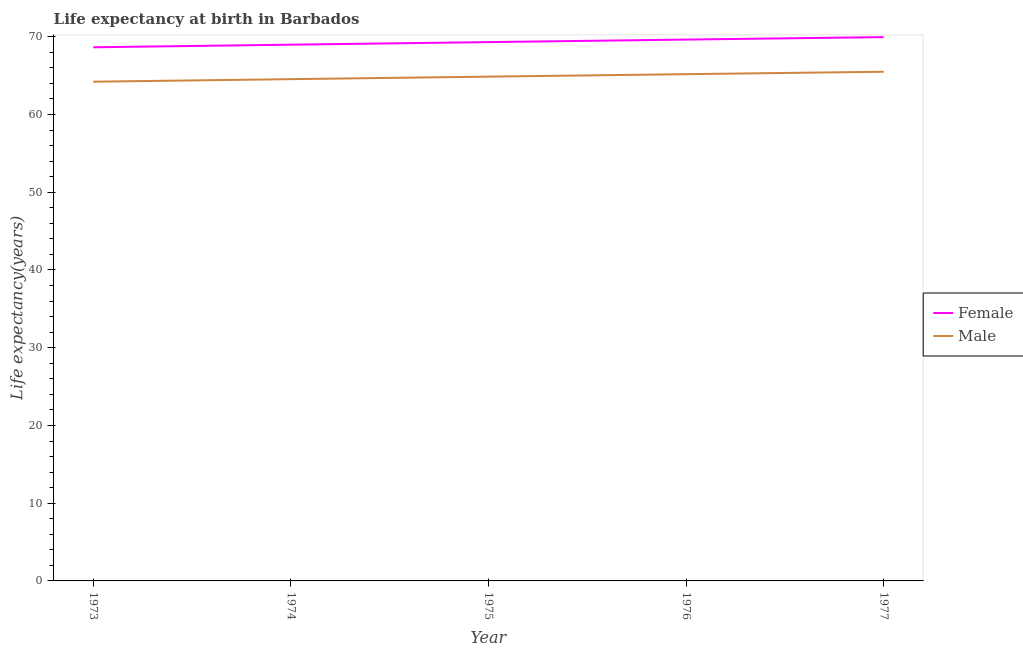How many different coloured lines are there?
Your response must be concise. 2. Does the line corresponding to life expectancy(male) intersect with the line corresponding to life expectancy(female)?
Your answer should be compact. No. What is the life expectancy(female) in 1975?
Provide a short and direct response. 69.32. Across all years, what is the maximum life expectancy(male)?
Offer a very short reply. 65.5. Across all years, what is the minimum life expectancy(female)?
Offer a terse response. 68.65. In which year was the life expectancy(male) maximum?
Your answer should be very brief. 1977. In which year was the life expectancy(male) minimum?
Ensure brevity in your answer.  1973. What is the total life expectancy(male) in the graph?
Provide a succinct answer. 324.34. What is the difference between the life expectancy(female) in 1974 and that in 1976?
Give a very brief answer. -0.66. What is the difference between the life expectancy(female) in 1973 and the life expectancy(male) in 1977?
Offer a very short reply. 3.15. What is the average life expectancy(female) per year?
Give a very brief answer. 69.31. In the year 1974, what is the difference between the life expectancy(female) and life expectancy(male)?
Provide a short and direct response. 4.44. What is the ratio of the life expectancy(female) in 1974 to that in 1977?
Your answer should be very brief. 0.99. Is the life expectancy(male) in 1974 less than that in 1976?
Your response must be concise. Yes. Is the difference between the life expectancy(female) in 1974 and 1977 greater than the difference between the life expectancy(male) in 1974 and 1977?
Make the answer very short. No. What is the difference between the highest and the second highest life expectancy(male)?
Your response must be concise. 0.31. What is the difference between the highest and the lowest life expectancy(male)?
Your answer should be very brief. 1.28. Is the sum of the life expectancy(female) in 1974 and 1975 greater than the maximum life expectancy(male) across all years?
Your answer should be very brief. Yes. Does the life expectancy(female) monotonically increase over the years?
Offer a very short reply. Yes. How many lines are there?
Your answer should be compact. 2. What is the difference between two consecutive major ticks on the Y-axis?
Ensure brevity in your answer.  10. Does the graph contain grids?
Provide a succinct answer. No. What is the title of the graph?
Ensure brevity in your answer.  Life expectancy at birth in Barbados. Does "Total Population" appear as one of the legend labels in the graph?
Offer a very short reply. No. What is the label or title of the X-axis?
Give a very brief answer. Year. What is the label or title of the Y-axis?
Your answer should be compact. Life expectancy(years). What is the Life expectancy(years) of Female in 1973?
Your answer should be compact. 68.65. What is the Life expectancy(years) in Male in 1973?
Ensure brevity in your answer.  64.22. What is the Life expectancy(years) of Female in 1974?
Provide a short and direct response. 68.99. What is the Life expectancy(years) of Male in 1974?
Provide a succinct answer. 64.55. What is the Life expectancy(years) of Female in 1975?
Make the answer very short. 69.32. What is the Life expectancy(years) of Male in 1975?
Ensure brevity in your answer.  64.87. What is the Life expectancy(years) of Female in 1976?
Give a very brief answer. 69.64. What is the Life expectancy(years) in Male in 1976?
Provide a succinct answer. 65.19. What is the Life expectancy(years) of Female in 1977?
Keep it short and to the point. 69.96. What is the Life expectancy(years) of Male in 1977?
Provide a succinct answer. 65.5. Across all years, what is the maximum Life expectancy(years) in Female?
Provide a succinct answer. 69.96. Across all years, what is the maximum Life expectancy(years) in Male?
Ensure brevity in your answer.  65.5. Across all years, what is the minimum Life expectancy(years) of Female?
Your answer should be very brief. 68.65. Across all years, what is the minimum Life expectancy(years) of Male?
Your answer should be compact. 64.22. What is the total Life expectancy(years) in Female in the graph?
Provide a succinct answer. 346.56. What is the total Life expectancy(years) of Male in the graph?
Your answer should be compact. 324.34. What is the difference between the Life expectancy(years) in Female in 1973 and that in 1974?
Offer a very short reply. -0.34. What is the difference between the Life expectancy(years) in Male in 1973 and that in 1974?
Offer a very short reply. -0.33. What is the difference between the Life expectancy(years) in Female in 1973 and that in 1975?
Make the answer very short. -0.67. What is the difference between the Life expectancy(years) of Male in 1973 and that in 1975?
Provide a short and direct response. -0.65. What is the difference between the Life expectancy(years) of Female in 1973 and that in 1976?
Keep it short and to the point. -0.99. What is the difference between the Life expectancy(years) of Male in 1973 and that in 1976?
Offer a terse response. -0.97. What is the difference between the Life expectancy(years) of Female in 1973 and that in 1977?
Your answer should be compact. -1.31. What is the difference between the Life expectancy(years) of Male in 1973 and that in 1977?
Your response must be concise. -1.28. What is the difference between the Life expectancy(years) of Female in 1974 and that in 1975?
Offer a very short reply. -0.33. What is the difference between the Life expectancy(years) in Male in 1974 and that in 1975?
Your answer should be very brief. -0.32. What is the difference between the Life expectancy(years) in Female in 1974 and that in 1976?
Provide a short and direct response. -0.66. What is the difference between the Life expectancy(years) of Male in 1974 and that in 1976?
Make the answer very short. -0.64. What is the difference between the Life expectancy(years) of Female in 1974 and that in 1977?
Ensure brevity in your answer.  -0.97. What is the difference between the Life expectancy(years) in Male in 1974 and that in 1977?
Your answer should be very brief. -0.95. What is the difference between the Life expectancy(years) in Female in 1975 and that in 1976?
Your answer should be compact. -0.33. What is the difference between the Life expectancy(years) of Male in 1975 and that in 1976?
Give a very brief answer. -0.32. What is the difference between the Life expectancy(years) in Female in 1975 and that in 1977?
Ensure brevity in your answer.  -0.64. What is the difference between the Life expectancy(years) of Male in 1975 and that in 1977?
Your answer should be compact. -0.63. What is the difference between the Life expectancy(years) in Female in 1976 and that in 1977?
Make the answer very short. -0.32. What is the difference between the Life expectancy(years) of Male in 1976 and that in 1977?
Your answer should be very brief. -0.31. What is the difference between the Life expectancy(years) of Female in 1973 and the Life expectancy(years) of Male in 1974?
Your response must be concise. 4.1. What is the difference between the Life expectancy(years) of Female in 1973 and the Life expectancy(years) of Male in 1975?
Your response must be concise. 3.78. What is the difference between the Life expectancy(years) of Female in 1973 and the Life expectancy(years) of Male in 1976?
Make the answer very short. 3.46. What is the difference between the Life expectancy(years) in Female in 1973 and the Life expectancy(years) in Male in 1977?
Provide a succinct answer. 3.15. What is the difference between the Life expectancy(years) in Female in 1974 and the Life expectancy(years) in Male in 1975?
Give a very brief answer. 4.11. What is the difference between the Life expectancy(years) in Female in 1974 and the Life expectancy(years) in Male in 1976?
Offer a very short reply. 3.8. What is the difference between the Life expectancy(years) of Female in 1974 and the Life expectancy(years) of Male in 1977?
Keep it short and to the point. 3.48. What is the difference between the Life expectancy(years) in Female in 1975 and the Life expectancy(years) in Male in 1976?
Your response must be concise. 4.13. What is the difference between the Life expectancy(years) of Female in 1975 and the Life expectancy(years) of Male in 1977?
Provide a succinct answer. 3.81. What is the difference between the Life expectancy(years) in Female in 1976 and the Life expectancy(years) in Male in 1977?
Keep it short and to the point. 4.14. What is the average Life expectancy(years) of Female per year?
Your answer should be very brief. 69.31. What is the average Life expectancy(years) of Male per year?
Keep it short and to the point. 64.87. In the year 1973, what is the difference between the Life expectancy(years) in Female and Life expectancy(years) in Male?
Offer a terse response. 4.43. In the year 1974, what is the difference between the Life expectancy(years) in Female and Life expectancy(years) in Male?
Your answer should be compact. 4.44. In the year 1975, what is the difference between the Life expectancy(years) of Female and Life expectancy(years) of Male?
Make the answer very short. 4.44. In the year 1976, what is the difference between the Life expectancy(years) in Female and Life expectancy(years) in Male?
Offer a terse response. 4.45. In the year 1977, what is the difference between the Life expectancy(years) of Female and Life expectancy(years) of Male?
Offer a very short reply. 4.46. What is the ratio of the Life expectancy(years) in Male in 1973 to that in 1975?
Provide a succinct answer. 0.99. What is the ratio of the Life expectancy(years) of Female in 1973 to that in 1976?
Offer a terse response. 0.99. What is the ratio of the Life expectancy(years) of Male in 1973 to that in 1976?
Your answer should be compact. 0.99. What is the ratio of the Life expectancy(years) in Female in 1973 to that in 1977?
Ensure brevity in your answer.  0.98. What is the ratio of the Life expectancy(years) in Male in 1973 to that in 1977?
Offer a terse response. 0.98. What is the ratio of the Life expectancy(years) of Female in 1974 to that in 1975?
Offer a very short reply. 1. What is the ratio of the Life expectancy(years) of Female in 1974 to that in 1976?
Offer a terse response. 0.99. What is the ratio of the Life expectancy(years) of Male in 1974 to that in 1976?
Offer a terse response. 0.99. What is the ratio of the Life expectancy(years) in Female in 1974 to that in 1977?
Offer a very short reply. 0.99. What is the ratio of the Life expectancy(years) of Male in 1974 to that in 1977?
Ensure brevity in your answer.  0.99. What is the ratio of the Life expectancy(years) in Female in 1975 to that in 1976?
Your answer should be very brief. 1. What is the ratio of the Life expectancy(years) of Male in 1975 to that in 1976?
Give a very brief answer. 1. What is the ratio of the Life expectancy(years) of Male in 1975 to that in 1977?
Keep it short and to the point. 0.99. What is the ratio of the Life expectancy(years) in Female in 1976 to that in 1977?
Your answer should be very brief. 1. What is the difference between the highest and the second highest Life expectancy(years) of Female?
Ensure brevity in your answer.  0.32. What is the difference between the highest and the second highest Life expectancy(years) in Male?
Give a very brief answer. 0.31. What is the difference between the highest and the lowest Life expectancy(years) of Female?
Your answer should be very brief. 1.31. What is the difference between the highest and the lowest Life expectancy(years) of Male?
Ensure brevity in your answer.  1.28. 